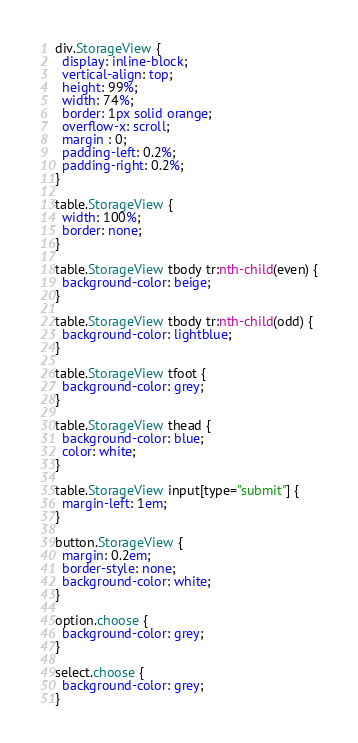Convert code to text. <code><loc_0><loc_0><loc_500><loc_500><_CSS_>div.StorageView {
  display: inline-block;
  vertical-align: top;
  height: 99%;
  width: 74%;
  border: 1px solid orange;
  overflow-x: scroll;
  margin : 0;
  padding-left: 0.2%;
  padding-right: 0.2%;
}

table.StorageView {
  width: 100%;
  border: none;
}

table.StorageView tbody tr:nth-child(even) {
  background-color: beige;
}

table.StorageView tbody tr:nth-child(odd) {
  background-color: lightblue;
}

table.StorageView tfoot {
  background-color: grey;
}

table.StorageView thead {
  background-color: blue;
  color: white;
}

table.StorageView input[type="submit"] {
  margin-left: 1em;
}

button.StorageView {
  margin: 0.2em;
  border-style: none;
  background-color: white;
}

option.choose {
  background-color: grey;
}

select.choose {
  background-color: grey;
}
</code> 